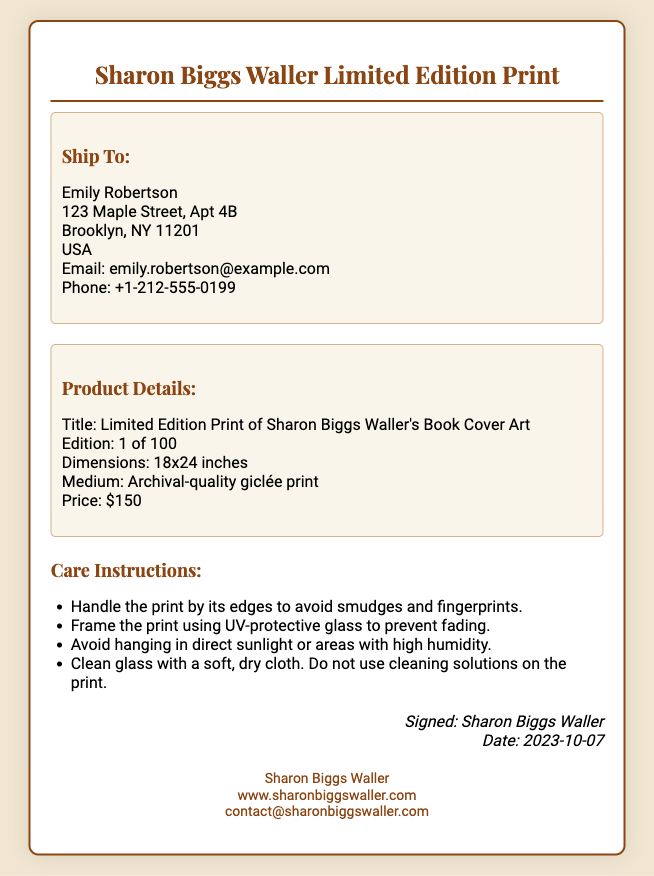What is the name of the buyer? The buyer's name is displayed in the "Ship To" section of the document.
Answer: Emily Robertson What is the title of the print? The title of the print is mentioned in the "Product Details" section.
Answer: Limited Edition Print of Sharon Biggs Waller's Book Cover Art What is the edition number of the print? The edition number is specified as part of the "Product Details" section.
Answer: 1 of 100 What are the dimensions of the print? The dimensions are listed under the "Product Details" section.
Answer: 18x24 inches What is the price of the print? The price is found in the "Product Details" section.
Answer: $150 What is the date of the signature? The date is included with the signature in the document.
Answer: 2023-10-07 How should the print be handled? The care instructions include specific handling advice.
Answer: Handle the print by its edges to avoid smudges and fingerprints What type of glass is recommended for framing? The care instructions specify the type of glass to use for framing.
Answer: UV-protective glass What is the contact email for Sharon Biggs Waller? The contact email is listed in the "artist-info" section of the document.
Answer: contact@sharonbiggswaller.com 